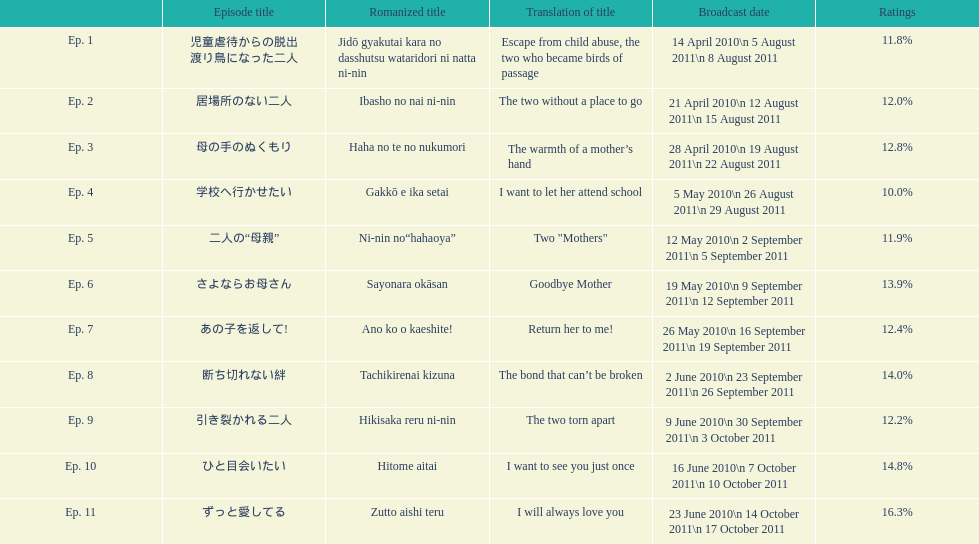Which episode was titled i want to let her attend school? Ep. 4. 